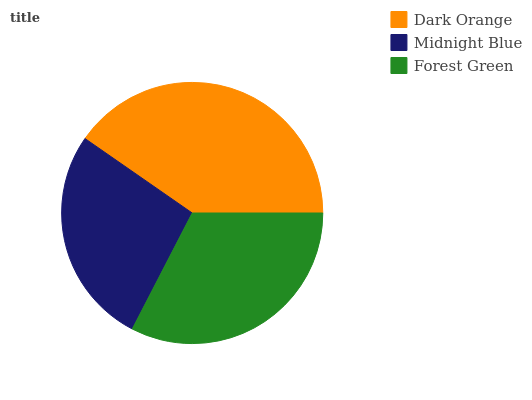Is Midnight Blue the minimum?
Answer yes or no. Yes. Is Dark Orange the maximum?
Answer yes or no. Yes. Is Forest Green the minimum?
Answer yes or no. No. Is Forest Green the maximum?
Answer yes or no. No. Is Forest Green greater than Midnight Blue?
Answer yes or no. Yes. Is Midnight Blue less than Forest Green?
Answer yes or no. Yes. Is Midnight Blue greater than Forest Green?
Answer yes or no. No. Is Forest Green less than Midnight Blue?
Answer yes or no. No. Is Forest Green the high median?
Answer yes or no. Yes. Is Forest Green the low median?
Answer yes or no. Yes. Is Dark Orange the high median?
Answer yes or no. No. Is Dark Orange the low median?
Answer yes or no. No. 